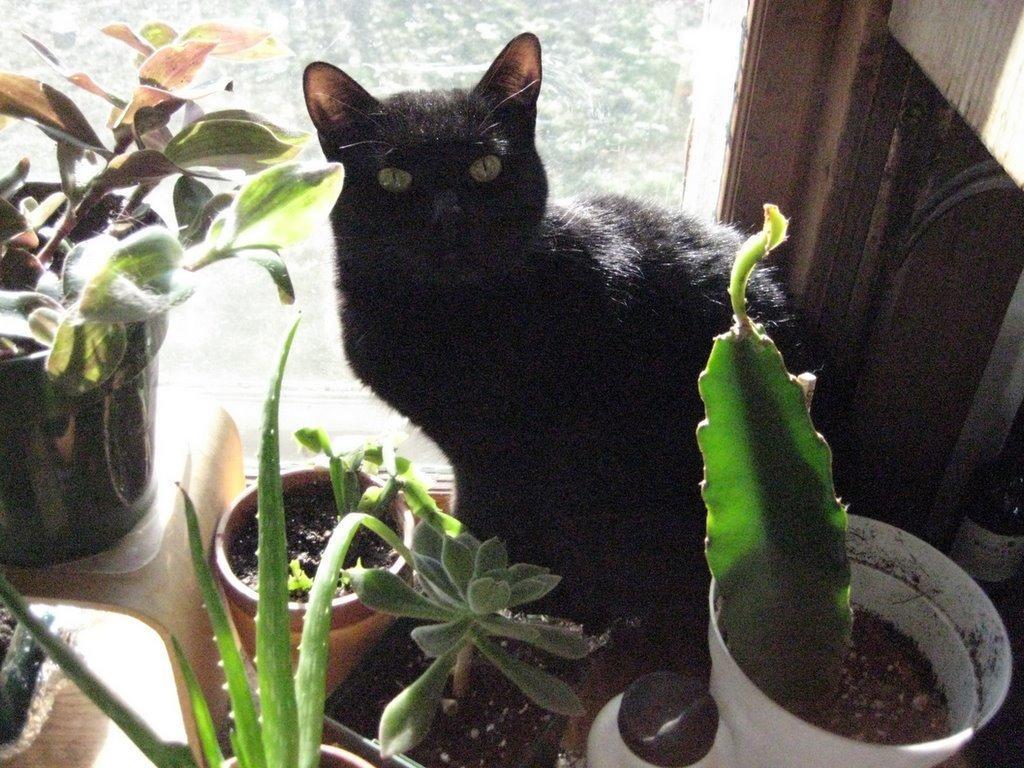In one or two sentences, can you explain what this image depicts? In this picture we can observe a black color cat sitting on the floor. We can observe some plant pots in front of this cat. There is an aloe vera plant. In the background we can observe trees and a glass window. 